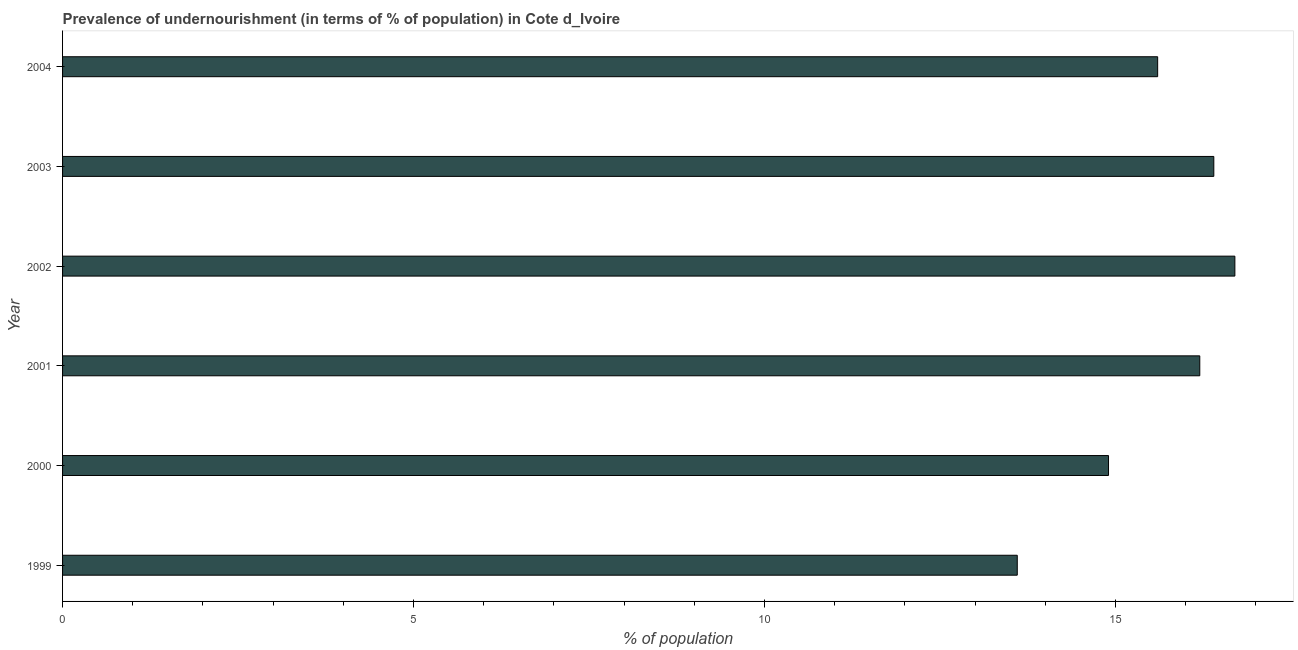What is the title of the graph?
Offer a terse response. Prevalence of undernourishment (in terms of % of population) in Cote d_Ivoire. What is the label or title of the X-axis?
Keep it short and to the point. % of population. What is the sum of the percentage of undernourished population?
Your response must be concise. 93.4. What is the average percentage of undernourished population per year?
Ensure brevity in your answer.  15.57. What is the median percentage of undernourished population?
Your answer should be compact. 15.9. In how many years, is the percentage of undernourished population greater than 4 %?
Offer a very short reply. 6. Do a majority of the years between 2003 and 2004 (inclusive) have percentage of undernourished population greater than 5 %?
Offer a terse response. Yes. What is the ratio of the percentage of undernourished population in 1999 to that in 2002?
Your answer should be very brief. 0.81. Is the percentage of undernourished population in 2000 less than that in 2001?
Ensure brevity in your answer.  Yes. Is the difference between the percentage of undernourished population in 2000 and 2001 greater than the difference between any two years?
Provide a succinct answer. No. Is the sum of the percentage of undernourished population in 2003 and 2004 greater than the maximum percentage of undernourished population across all years?
Your answer should be very brief. Yes. How many years are there in the graph?
Your answer should be compact. 6. What is the difference between two consecutive major ticks on the X-axis?
Provide a short and direct response. 5. What is the % of population of 1999?
Provide a succinct answer. 13.6. What is the % of population in 2000?
Keep it short and to the point. 14.9. What is the % of population of 2003?
Your response must be concise. 16.4. What is the difference between the % of population in 1999 and 2000?
Make the answer very short. -1.3. What is the difference between the % of population in 1999 and 2003?
Ensure brevity in your answer.  -2.8. What is the difference between the % of population in 1999 and 2004?
Make the answer very short. -2. What is the difference between the % of population in 2000 and 2001?
Provide a succinct answer. -1.3. What is the difference between the % of population in 2000 and 2003?
Give a very brief answer. -1.5. What is the difference between the % of population in 2000 and 2004?
Offer a terse response. -0.7. What is the difference between the % of population in 2001 and 2002?
Provide a short and direct response. -0.5. What is the difference between the % of population in 2001 and 2003?
Keep it short and to the point. -0.2. What is the difference between the % of population in 2001 and 2004?
Ensure brevity in your answer.  0.6. What is the difference between the % of population in 2002 and 2003?
Ensure brevity in your answer.  0.3. What is the difference between the % of population in 2003 and 2004?
Your answer should be very brief. 0.8. What is the ratio of the % of population in 1999 to that in 2001?
Give a very brief answer. 0.84. What is the ratio of the % of population in 1999 to that in 2002?
Ensure brevity in your answer.  0.81. What is the ratio of the % of population in 1999 to that in 2003?
Keep it short and to the point. 0.83. What is the ratio of the % of population in 1999 to that in 2004?
Give a very brief answer. 0.87. What is the ratio of the % of population in 2000 to that in 2001?
Provide a succinct answer. 0.92. What is the ratio of the % of population in 2000 to that in 2002?
Your answer should be very brief. 0.89. What is the ratio of the % of population in 2000 to that in 2003?
Ensure brevity in your answer.  0.91. What is the ratio of the % of population in 2000 to that in 2004?
Your answer should be compact. 0.95. What is the ratio of the % of population in 2001 to that in 2002?
Your answer should be very brief. 0.97. What is the ratio of the % of population in 2001 to that in 2003?
Your response must be concise. 0.99. What is the ratio of the % of population in 2001 to that in 2004?
Offer a very short reply. 1.04. What is the ratio of the % of population in 2002 to that in 2004?
Offer a very short reply. 1.07. What is the ratio of the % of population in 2003 to that in 2004?
Give a very brief answer. 1.05. 